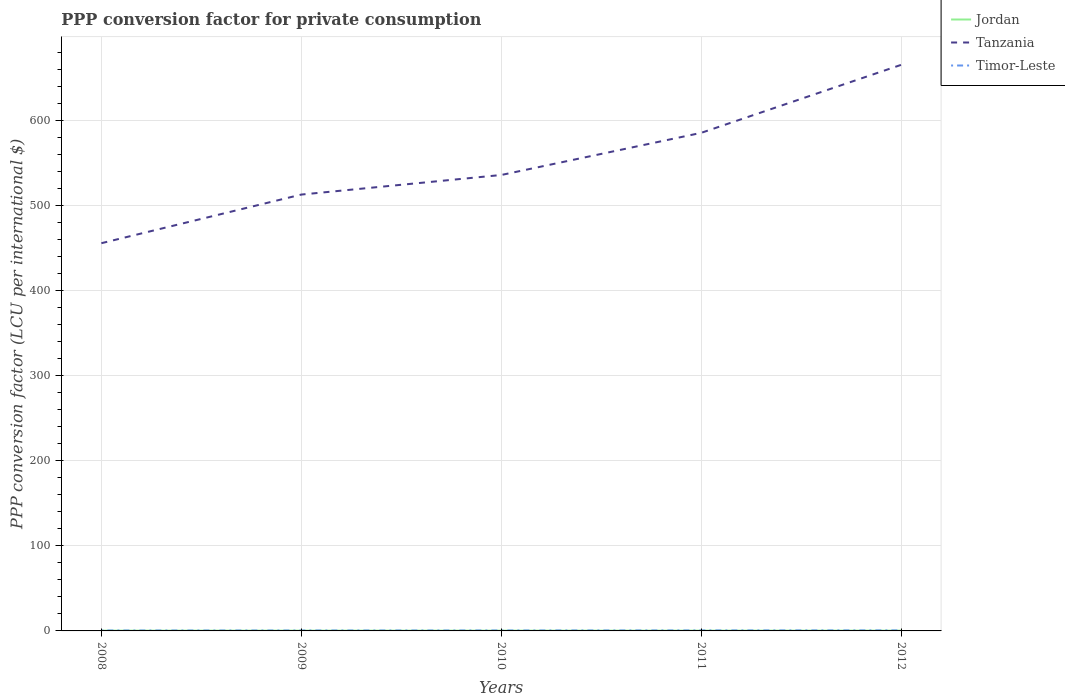How many different coloured lines are there?
Ensure brevity in your answer.  3. Does the line corresponding to Jordan intersect with the line corresponding to Timor-Leste?
Make the answer very short. No. Across all years, what is the maximum PPP conversion factor for private consumption in Timor-Leste?
Offer a terse response. 0.48. What is the total PPP conversion factor for private consumption in Tanzania in the graph?
Keep it short and to the point. -79.92. What is the difference between the highest and the second highest PPP conversion factor for private consumption in Jordan?
Your response must be concise. 0.02. What is the difference between the highest and the lowest PPP conversion factor for private consumption in Timor-Leste?
Give a very brief answer. 2. Is the PPP conversion factor for private consumption in Tanzania strictly greater than the PPP conversion factor for private consumption in Jordan over the years?
Give a very brief answer. No. How many lines are there?
Give a very brief answer. 3. How many years are there in the graph?
Make the answer very short. 5. Are the values on the major ticks of Y-axis written in scientific E-notation?
Offer a very short reply. No. Does the graph contain any zero values?
Provide a succinct answer. No. Where does the legend appear in the graph?
Your answer should be very brief. Top right. How many legend labels are there?
Your response must be concise. 3. What is the title of the graph?
Your answer should be compact. PPP conversion factor for private consumption. Does "Guam" appear as one of the legend labels in the graph?
Ensure brevity in your answer.  No. What is the label or title of the Y-axis?
Ensure brevity in your answer.  PPP conversion factor (LCU per international $). What is the PPP conversion factor (LCU per international $) in Jordan in 2008?
Provide a succinct answer. 0.31. What is the PPP conversion factor (LCU per international $) of Tanzania in 2008?
Make the answer very short. 455.8. What is the PPP conversion factor (LCU per international $) of Timor-Leste in 2008?
Offer a terse response. 0.48. What is the PPP conversion factor (LCU per international $) in Jordan in 2009?
Provide a succinct answer. 0.31. What is the PPP conversion factor (LCU per international $) in Tanzania in 2009?
Provide a short and direct response. 512.97. What is the PPP conversion factor (LCU per international $) of Timor-Leste in 2009?
Your answer should be compact. 0.49. What is the PPP conversion factor (LCU per international $) of Jordan in 2010?
Ensure brevity in your answer.  0.32. What is the PPP conversion factor (LCU per international $) in Tanzania in 2010?
Provide a succinct answer. 535.98. What is the PPP conversion factor (LCU per international $) in Timor-Leste in 2010?
Ensure brevity in your answer.  0.51. What is the PPP conversion factor (LCU per international $) in Jordan in 2011?
Ensure brevity in your answer.  0.32. What is the PPP conversion factor (LCU per international $) in Tanzania in 2011?
Offer a terse response. 585.52. What is the PPP conversion factor (LCU per international $) of Timor-Leste in 2011?
Keep it short and to the point. 0.56. What is the PPP conversion factor (LCU per international $) in Jordan in 2012?
Your response must be concise. 0.33. What is the PPP conversion factor (LCU per international $) in Tanzania in 2012?
Your answer should be compact. 665.44. What is the PPP conversion factor (LCU per international $) of Timor-Leste in 2012?
Keep it short and to the point. 0.61. Across all years, what is the maximum PPP conversion factor (LCU per international $) of Jordan?
Give a very brief answer. 0.33. Across all years, what is the maximum PPP conversion factor (LCU per international $) of Tanzania?
Provide a short and direct response. 665.44. Across all years, what is the maximum PPP conversion factor (LCU per international $) of Timor-Leste?
Ensure brevity in your answer.  0.61. Across all years, what is the minimum PPP conversion factor (LCU per international $) in Jordan?
Provide a short and direct response. 0.31. Across all years, what is the minimum PPP conversion factor (LCU per international $) in Tanzania?
Keep it short and to the point. 455.8. Across all years, what is the minimum PPP conversion factor (LCU per international $) in Timor-Leste?
Your answer should be very brief. 0.48. What is the total PPP conversion factor (LCU per international $) of Jordan in the graph?
Your answer should be very brief. 1.57. What is the total PPP conversion factor (LCU per international $) of Tanzania in the graph?
Provide a succinct answer. 2755.71. What is the total PPP conversion factor (LCU per international $) of Timor-Leste in the graph?
Ensure brevity in your answer.  2.65. What is the difference between the PPP conversion factor (LCU per international $) of Tanzania in 2008 and that in 2009?
Your response must be concise. -57.17. What is the difference between the PPP conversion factor (LCU per international $) in Timor-Leste in 2008 and that in 2009?
Your response must be concise. -0. What is the difference between the PPP conversion factor (LCU per international $) of Jordan in 2008 and that in 2010?
Offer a terse response. -0.01. What is the difference between the PPP conversion factor (LCU per international $) of Tanzania in 2008 and that in 2010?
Make the answer very short. -80.18. What is the difference between the PPP conversion factor (LCU per international $) of Timor-Leste in 2008 and that in 2010?
Offer a very short reply. -0.03. What is the difference between the PPP conversion factor (LCU per international $) of Jordan in 2008 and that in 2011?
Keep it short and to the point. -0.01. What is the difference between the PPP conversion factor (LCU per international $) of Tanzania in 2008 and that in 2011?
Keep it short and to the point. -129.72. What is the difference between the PPP conversion factor (LCU per international $) in Timor-Leste in 2008 and that in 2011?
Your answer should be very brief. -0.08. What is the difference between the PPP conversion factor (LCU per international $) in Jordan in 2008 and that in 2012?
Provide a succinct answer. -0.02. What is the difference between the PPP conversion factor (LCU per international $) in Tanzania in 2008 and that in 2012?
Offer a terse response. -209.64. What is the difference between the PPP conversion factor (LCU per international $) in Timor-Leste in 2008 and that in 2012?
Make the answer very short. -0.13. What is the difference between the PPP conversion factor (LCU per international $) of Jordan in 2009 and that in 2010?
Give a very brief answer. -0.01. What is the difference between the PPP conversion factor (LCU per international $) in Tanzania in 2009 and that in 2010?
Your answer should be compact. -23.01. What is the difference between the PPP conversion factor (LCU per international $) in Timor-Leste in 2009 and that in 2010?
Keep it short and to the point. -0.02. What is the difference between the PPP conversion factor (LCU per international $) of Jordan in 2009 and that in 2011?
Ensure brevity in your answer.  -0.01. What is the difference between the PPP conversion factor (LCU per international $) of Tanzania in 2009 and that in 2011?
Provide a short and direct response. -72.55. What is the difference between the PPP conversion factor (LCU per international $) in Timor-Leste in 2009 and that in 2011?
Provide a succinct answer. -0.08. What is the difference between the PPP conversion factor (LCU per international $) in Jordan in 2009 and that in 2012?
Make the answer very short. -0.02. What is the difference between the PPP conversion factor (LCU per international $) of Tanzania in 2009 and that in 2012?
Offer a terse response. -152.47. What is the difference between the PPP conversion factor (LCU per international $) in Timor-Leste in 2009 and that in 2012?
Your response must be concise. -0.13. What is the difference between the PPP conversion factor (LCU per international $) in Jordan in 2010 and that in 2011?
Provide a succinct answer. -0. What is the difference between the PPP conversion factor (LCU per international $) in Tanzania in 2010 and that in 2011?
Give a very brief answer. -49.54. What is the difference between the PPP conversion factor (LCU per international $) of Timor-Leste in 2010 and that in 2011?
Make the answer very short. -0.05. What is the difference between the PPP conversion factor (LCU per international $) in Jordan in 2010 and that in 2012?
Ensure brevity in your answer.  -0.01. What is the difference between the PPP conversion factor (LCU per international $) of Tanzania in 2010 and that in 2012?
Provide a short and direct response. -129.46. What is the difference between the PPP conversion factor (LCU per international $) in Timor-Leste in 2010 and that in 2012?
Keep it short and to the point. -0.1. What is the difference between the PPP conversion factor (LCU per international $) in Jordan in 2011 and that in 2012?
Provide a short and direct response. -0.01. What is the difference between the PPP conversion factor (LCU per international $) of Tanzania in 2011 and that in 2012?
Offer a very short reply. -79.92. What is the difference between the PPP conversion factor (LCU per international $) of Timor-Leste in 2011 and that in 2012?
Offer a terse response. -0.05. What is the difference between the PPP conversion factor (LCU per international $) of Jordan in 2008 and the PPP conversion factor (LCU per international $) of Tanzania in 2009?
Provide a short and direct response. -512.66. What is the difference between the PPP conversion factor (LCU per international $) in Jordan in 2008 and the PPP conversion factor (LCU per international $) in Timor-Leste in 2009?
Provide a succinct answer. -0.18. What is the difference between the PPP conversion factor (LCU per international $) of Tanzania in 2008 and the PPP conversion factor (LCU per international $) of Timor-Leste in 2009?
Make the answer very short. 455.31. What is the difference between the PPP conversion factor (LCU per international $) in Jordan in 2008 and the PPP conversion factor (LCU per international $) in Tanzania in 2010?
Provide a short and direct response. -535.68. What is the difference between the PPP conversion factor (LCU per international $) in Jordan in 2008 and the PPP conversion factor (LCU per international $) in Timor-Leste in 2010?
Offer a very short reply. -0.2. What is the difference between the PPP conversion factor (LCU per international $) of Tanzania in 2008 and the PPP conversion factor (LCU per international $) of Timor-Leste in 2010?
Offer a very short reply. 455.29. What is the difference between the PPP conversion factor (LCU per international $) of Jordan in 2008 and the PPP conversion factor (LCU per international $) of Tanzania in 2011?
Your response must be concise. -585.21. What is the difference between the PPP conversion factor (LCU per international $) in Jordan in 2008 and the PPP conversion factor (LCU per international $) in Timor-Leste in 2011?
Offer a very short reply. -0.26. What is the difference between the PPP conversion factor (LCU per international $) of Tanzania in 2008 and the PPP conversion factor (LCU per international $) of Timor-Leste in 2011?
Your response must be concise. 455.24. What is the difference between the PPP conversion factor (LCU per international $) of Jordan in 2008 and the PPP conversion factor (LCU per international $) of Tanzania in 2012?
Provide a short and direct response. -665.13. What is the difference between the PPP conversion factor (LCU per international $) of Jordan in 2008 and the PPP conversion factor (LCU per international $) of Timor-Leste in 2012?
Your response must be concise. -0.31. What is the difference between the PPP conversion factor (LCU per international $) of Tanzania in 2008 and the PPP conversion factor (LCU per international $) of Timor-Leste in 2012?
Your answer should be very brief. 455.19. What is the difference between the PPP conversion factor (LCU per international $) in Jordan in 2009 and the PPP conversion factor (LCU per international $) in Tanzania in 2010?
Your response must be concise. -535.68. What is the difference between the PPP conversion factor (LCU per international $) in Jordan in 2009 and the PPP conversion factor (LCU per international $) in Timor-Leste in 2010?
Provide a succinct answer. -0.2. What is the difference between the PPP conversion factor (LCU per international $) of Tanzania in 2009 and the PPP conversion factor (LCU per international $) of Timor-Leste in 2010?
Offer a terse response. 512.46. What is the difference between the PPP conversion factor (LCU per international $) in Jordan in 2009 and the PPP conversion factor (LCU per international $) in Tanzania in 2011?
Ensure brevity in your answer.  -585.22. What is the difference between the PPP conversion factor (LCU per international $) of Jordan in 2009 and the PPP conversion factor (LCU per international $) of Timor-Leste in 2011?
Offer a terse response. -0.26. What is the difference between the PPP conversion factor (LCU per international $) of Tanzania in 2009 and the PPP conversion factor (LCU per international $) of Timor-Leste in 2011?
Your response must be concise. 512.41. What is the difference between the PPP conversion factor (LCU per international $) in Jordan in 2009 and the PPP conversion factor (LCU per international $) in Tanzania in 2012?
Keep it short and to the point. -665.13. What is the difference between the PPP conversion factor (LCU per international $) in Jordan in 2009 and the PPP conversion factor (LCU per international $) in Timor-Leste in 2012?
Make the answer very short. -0.31. What is the difference between the PPP conversion factor (LCU per international $) in Tanzania in 2009 and the PPP conversion factor (LCU per international $) in Timor-Leste in 2012?
Make the answer very short. 512.35. What is the difference between the PPP conversion factor (LCU per international $) in Jordan in 2010 and the PPP conversion factor (LCU per international $) in Tanzania in 2011?
Provide a succinct answer. -585.2. What is the difference between the PPP conversion factor (LCU per international $) of Jordan in 2010 and the PPP conversion factor (LCU per international $) of Timor-Leste in 2011?
Keep it short and to the point. -0.25. What is the difference between the PPP conversion factor (LCU per international $) in Tanzania in 2010 and the PPP conversion factor (LCU per international $) in Timor-Leste in 2011?
Give a very brief answer. 535.42. What is the difference between the PPP conversion factor (LCU per international $) in Jordan in 2010 and the PPP conversion factor (LCU per international $) in Tanzania in 2012?
Your answer should be compact. -665.12. What is the difference between the PPP conversion factor (LCU per international $) of Jordan in 2010 and the PPP conversion factor (LCU per international $) of Timor-Leste in 2012?
Ensure brevity in your answer.  -0.3. What is the difference between the PPP conversion factor (LCU per international $) of Tanzania in 2010 and the PPP conversion factor (LCU per international $) of Timor-Leste in 2012?
Your answer should be compact. 535.37. What is the difference between the PPP conversion factor (LCU per international $) in Jordan in 2011 and the PPP conversion factor (LCU per international $) in Tanzania in 2012?
Your response must be concise. -665.12. What is the difference between the PPP conversion factor (LCU per international $) in Jordan in 2011 and the PPP conversion factor (LCU per international $) in Timor-Leste in 2012?
Offer a terse response. -0.3. What is the difference between the PPP conversion factor (LCU per international $) of Tanzania in 2011 and the PPP conversion factor (LCU per international $) of Timor-Leste in 2012?
Keep it short and to the point. 584.91. What is the average PPP conversion factor (LCU per international $) of Jordan per year?
Offer a very short reply. 0.31. What is the average PPP conversion factor (LCU per international $) in Tanzania per year?
Your response must be concise. 551.14. What is the average PPP conversion factor (LCU per international $) in Timor-Leste per year?
Keep it short and to the point. 0.53. In the year 2008, what is the difference between the PPP conversion factor (LCU per international $) in Jordan and PPP conversion factor (LCU per international $) in Tanzania?
Ensure brevity in your answer.  -455.49. In the year 2008, what is the difference between the PPP conversion factor (LCU per international $) of Jordan and PPP conversion factor (LCU per international $) of Timor-Leste?
Your answer should be very brief. -0.17. In the year 2008, what is the difference between the PPP conversion factor (LCU per international $) in Tanzania and PPP conversion factor (LCU per international $) in Timor-Leste?
Provide a succinct answer. 455.32. In the year 2009, what is the difference between the PPP conversion factor (LCU per international $) in Jordan and PPP conversion factor (LCU per international $) in Tanzania?
Your answer should be very brief. -512.66. In the year 2009, what is the difference between the PPP conversion factor (LCU per international $) in Jordan and PPP conversion factor (LCU per international $) in Timor-Leste?
Your answer should be very brief. -0.18. In the year 2009, what is the difference between the PPP conversion factor (LCU per international $) in Tanzania and PPP conversion factor (LCU per international $) in Timor-Leste?
Your response must be concise. 512.48. In the year 2010, what is the difference between the PPP conversion factor (LCU per international $) of Jordan and PPP conversion factor (LCU per international $) of Tanzania?
Offer a terse response. -535.67. In the year 2010, what is the difference between the PPP conversion factor (LCU per international $) of Jordan and PPP conversion factor (LCU per international $) of Timor-Leste?
Provide a short and direct response. -0.19. In the year 2010, what is the difference between the PPP conversion factor (LCU per international $) in Tanzania and PPP conversion factor (LCU per international $) in Timor-Leste?
Offer a terse response. 535.47. In the year 2011, what is the difference between the PPP conversion factor (LCU per international $) of Jordan and PPP conversion factor (LCU per international $) of Tanzania?
Ensure brevity in your answer.  -585.2. In the year 2011, what is the difference between the PPP conversion factor (LCU per international $) in Jordan and PPP conversion factor (LCU per international $) in Timor-Leste?
Give a very brief answer. -0.24. In the year 2011, what is the difference between the PPP conversion factor (LCU per international $) in Tanzania and PPP conversion factor (LCU per international $) in Timor-Leste?
Give a very brief answer. 584.96. In the year 2012, what is the difference between the PPP conversion factor (LCU per international $) of Jordan and PPP conversion factor (LCU per international $) of Tanzania?
Your answer should be very brief. -665.11. In the year 2012, what is the difference between the PPP conversion factor (LCU per international $) of Jordan and PPP conversion factor (LCU per international $) of Timor-Leste?
Your response must be concise. -0.29. In the year 2012, what is the difference between the PPP conversion factor (LCU per international $) in Tanzania and PPP conversion factor (LCU per international $) in Timor-Leste?
Offer a very short reply. 664.83. What is the ratio of the PPP conversion factor (LCU per international $) in Jordan in 2008 to that in 2009?
Make the answer very short. 1. What is the ratio of the PPP conversion factor (LCU per international $) in Tanzania in 2008 to that in 2009?
Make the answer very short. 0.89. What is the ratio of the PPP conversion factor (LCU per international $) of Timor-Leste in 2008 to that in 2009?
Your response must be concise. 0.99. What is the ratio of the PPP conversion factor (LCU per international $) in Tanzania in 2008 to that in 2010?
Keep it short and to the point. 0.85. What is the ratio of the PPP conversion factor (LCU per international $) in Timor-Leste in 2008 to that in 2010?
Offer a terse response. 0.94. What is the ratio of the PPP conversion factor (LCU per international $) in Jordan in 2008 to that in 2011?
Offer a very short reply. 0.96. What is the ratio of the PPP conversion factor (LCU per international $) of Tanzania in 2008 to that in 2011?
Your response must be concise. 0.78. What is the ratio of the PPP conversion factor (LCU per international $) in Timor-Leste in 2008 to that in 2011?
Your response must be concise. 0.86. What is the ratio of the PPP conversion factor (LCU per international $) of Jordan in 2008 to that in 2012?
Provide a succinct answer. 0.93. What is the ratio of the PPP conversion factor (LCU per international $) in Tanzania in 2008 to that in 2012?
Keep it short and to the point. 0.69. What is the ratio of the PPP conversion factor (LCU per international $) of Timor-Leste in 2008 to that in 2012?
Ensure brevity in your answer.  0.78. What is the ratio of the PPP conversion factor (LCU per international $) in Jordan in 2009 to that in 2010?
Offer a terse response. 0.97. What is the ratio of the PPP conversion factor (LCU per international $) in Tanzania in 2009 to that in 2010?
Provide a succinct answer. 0.96. What is the ratio of the PPP conversion factor (LCU per international $) in Timor-Leste in 2009 to that in 2010?
Make the answer very short. 0.95. What is the ratio of the PPP conversion factor (LCU per international $) in Jordan in 2009 to that in 2011?
Provide a short and direct response. 0.96. What is the ratio of the PPP conversion factor (LCU per international $) of Tanzania in 2009 to that in 2011?
Provide a succinct answer. 0.88. What is the ratio of the PPP conversion factor (LCU per international $) in Timor-Leste in 2009 to that in 2011?
Provide a short and direct response. 0.87. What is the ratio of the PPP conversion factor (LCU per international $) in Jordan in 2009 to that in 2012?
Provide a succinct answer. 0.93. What is the ratio of the PPP conversion factor (LCU per international $) of Tanzania in 2009 to that in 2012?
Provide a succinct answer. 0.77. What is the ratio of the PPP conversion factor (LCU per international $) in Timor-Leste in 2009 to that in 2012?
Offer a very short reply. 0.79. What is the ratio of the PPP conversion factor (LCU per international $) of Tanzania in 2010 to that in 2011?
Your response must be concise. 0.92. What is the ratio of the PPP conversion factor (LCU per international $) of Timor-Leste in 2010 to that in 2011?
Keep it short and to the point. 0.91. What is the ratio of the PPP conversion factor (LCU per international $) of Jordan in 2010 to that in 2012?
Your answer should be very brief. 0.96. What is the ratio of the PPP conversion factor (LCU per international $) in Tanzania in 2010 to that in 2012?
Offer a very short reply. 0.81. What is the ratio of the PPP conversion factor (LCU per international $) of Timor-Leste in 2010 to that in 2012?
Your answer should be very brief. 0.83. What is the ratio of the PPP conversion factor (LCU per international $) of Jordan in 2011 to that in 2012?
Make the answer very short. 0.97. What is the ratio of the PPP conversion factor (LCU per international $) of Tanzania in 2011 to that in 2012?
Provide a succinct answer. 0.88. What is the difference between the highest and the second highest PPP conversion factor (LCU per international $) in Jordan?
Your response must be concise. 0.01. What is the difference between the highest and the second highest PPP conversion factor (LCU per international $) of Tanzania?
Offer a terse response. 79.92. What is the difference between the highest and the second highest PPP conversion factor (LCU per international $) of Timor-Leste?
Make the answer very short. 0.05. What is the difference between the highest and the lowest PPP conversion factor (LCU per international $) in Jordan?
Give a very brief answer. 0.02. What is the difference between the highest and the lowest PPP conversion factor (LCU per international $) of Tanzania?
Make the answer very short. 209.64. What is the difference between the highest and the lowest PPP conversion factor (LCU per international $) of Timor-Leste?
Your answer should be compact. 0.13. 